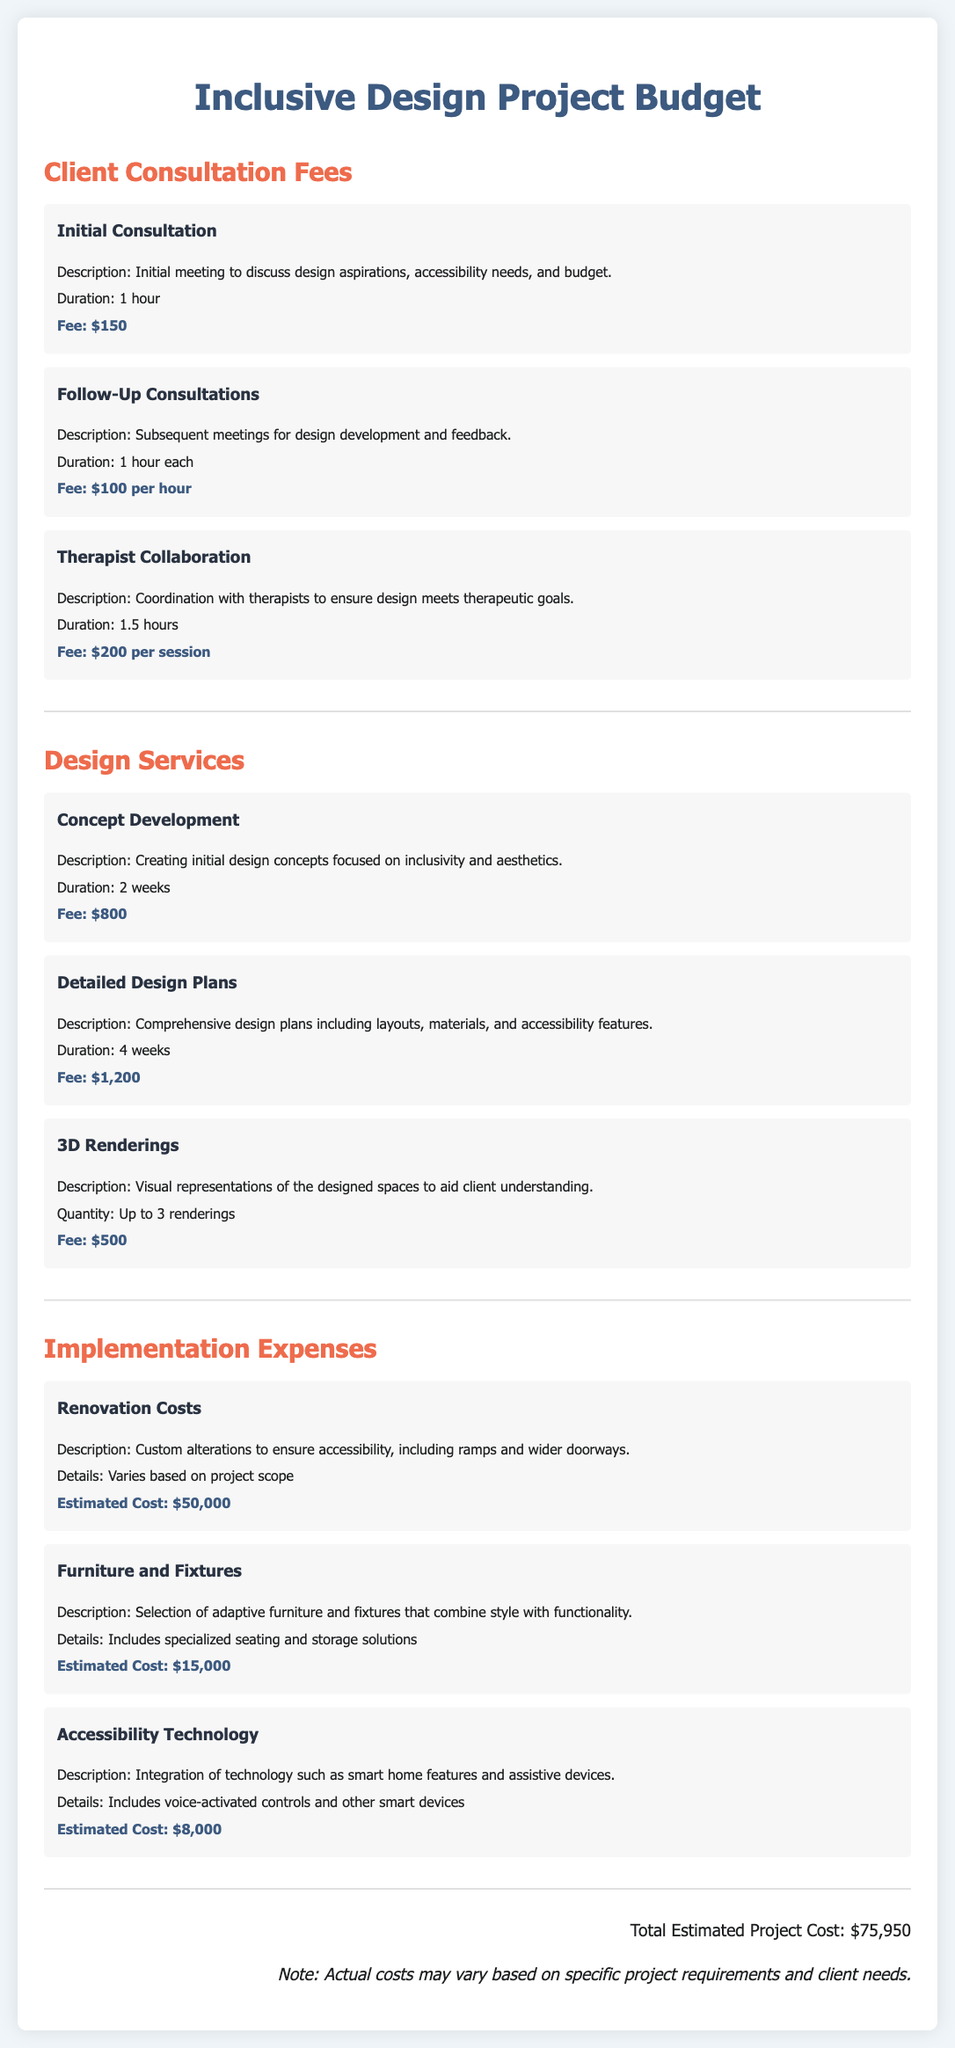What is the fee for the initial consultation? The fee for the initial consultation is mentioned in the section on Client Consultation Fees.
Answer: $150 How long is the therapist collaboration session? The duration of the therapist collaboration session is specified in the document.
Answer: 1.5 hours What is the estimated cost for renovation? The cost for renovation is provided in the Implementation Expenses section.
Answer: $50,000 How many weeks does the concept development take? The duration for concept development is detailed in the Design Services section.
Answer: 2 weeks What is the total estimated project cost? The total estimated project cost is stated at the end of the document.
Answer: $75,950 What fee is charged for follow-up consultations? The fee for follow-up consultations is listed under Client Consultation Fees.
Answer: $100 per hour What does the 3D renderings fee cover? The fee thought for 3D renderings pertains to visual aids mentioned in the Design Services.
Answer: Up to 3 renderings What is included in the furniture and fixtures estimate? The description specifies the type of furniture and fixtures considered for accessibility.
Answer: Adaptive furniture and fixtures How long do detailed design plans take? The duration for detailed design plans is mentioned in the Design Services section.
Answer: 4 weeks 